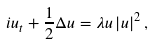<formula> <loc_0><loc_0><loc_500><loc_500>i u _ { t } + \frac { 1 } { 2 } \Delta u = \lambda u \left | u \right | ^ { 2 } ,</formula> 